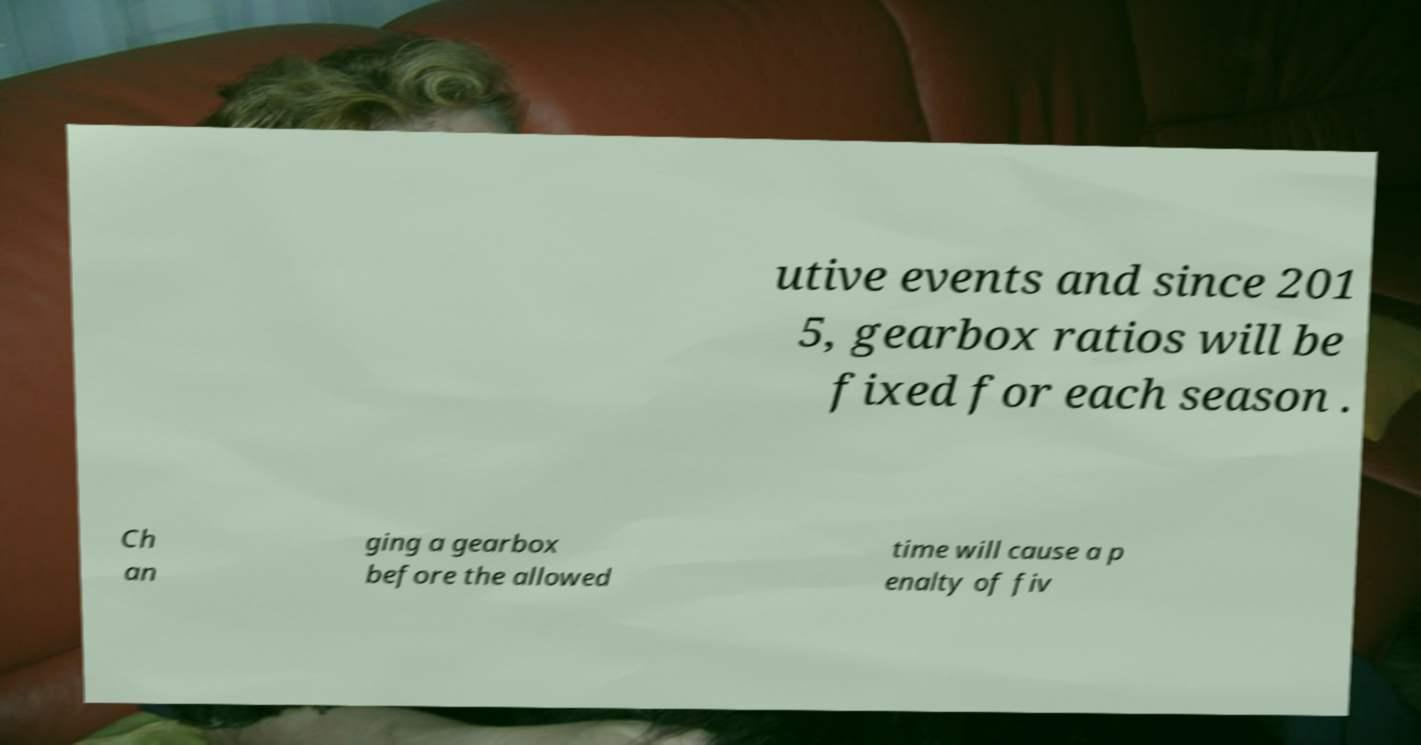Can you accurately transcribe the text from the provided image for me? utive events and since 201 5, gearbox ratios will be fixed for each season . Ch an ging a gearbox before the allowed time will cause a p enalty of fiv 